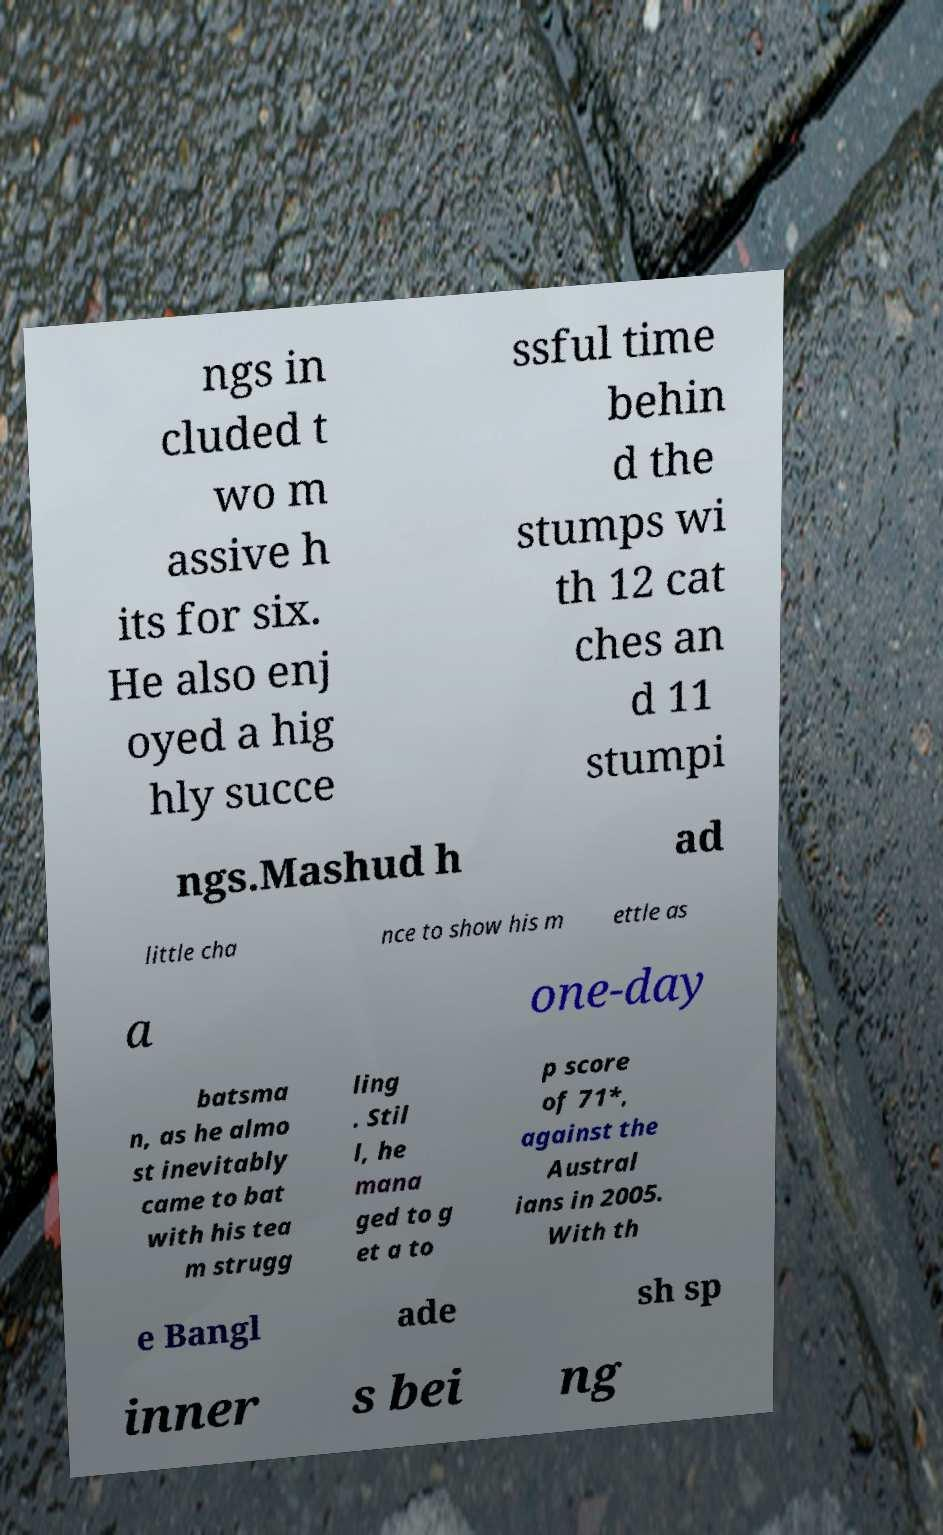What messages or text are displayed in this image? I need them in a readable, typed format. ngs in cluded t wo m assive h its for six. He also enj oyed a hig hly succe ssful time behin d the stumps wi th 12 cat ches an d 11 stumpi ngs.Mashud h ad little cha nce to show his m ettle as a one-day batsma n, as he almo st inevitably came to bat with his tea m strugg ling . Stil l, he mana ged to g et a to p score of 71*, against the Austral ians in 2005. With th e Bangl ade sh sp inner s bei ng 